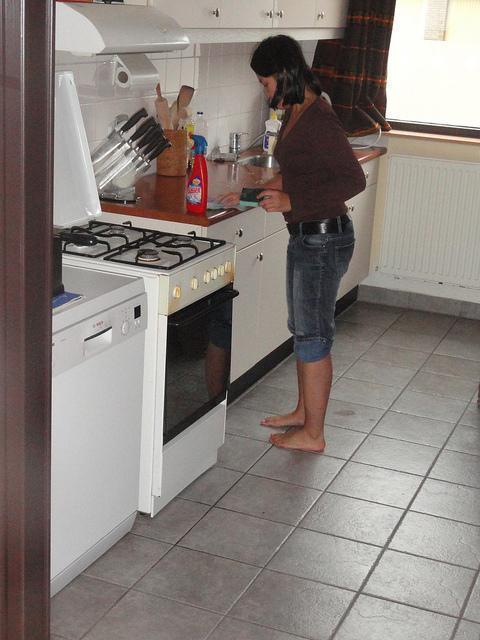What is the person doing in the kitchen?
Make your selection and explain in format: 'Answer: answer
Rationale: rationale.'
Options: Sleeping, meddling, cleaning, cooking. Answer: cleaning.
Rationale: The person cleans. How are dishes cleaned here?
Answer the question by selecting the correct answer among the 4 following choices and explain your choice with a short sentence. The answer should be formatted with the following format: `Answer: choice
Rationale: rationale.`
Options: They aren't, dishwashing machine, sponged, air washed. Answer: dishwashing machine.
Rationale: She has a dishwasher. 